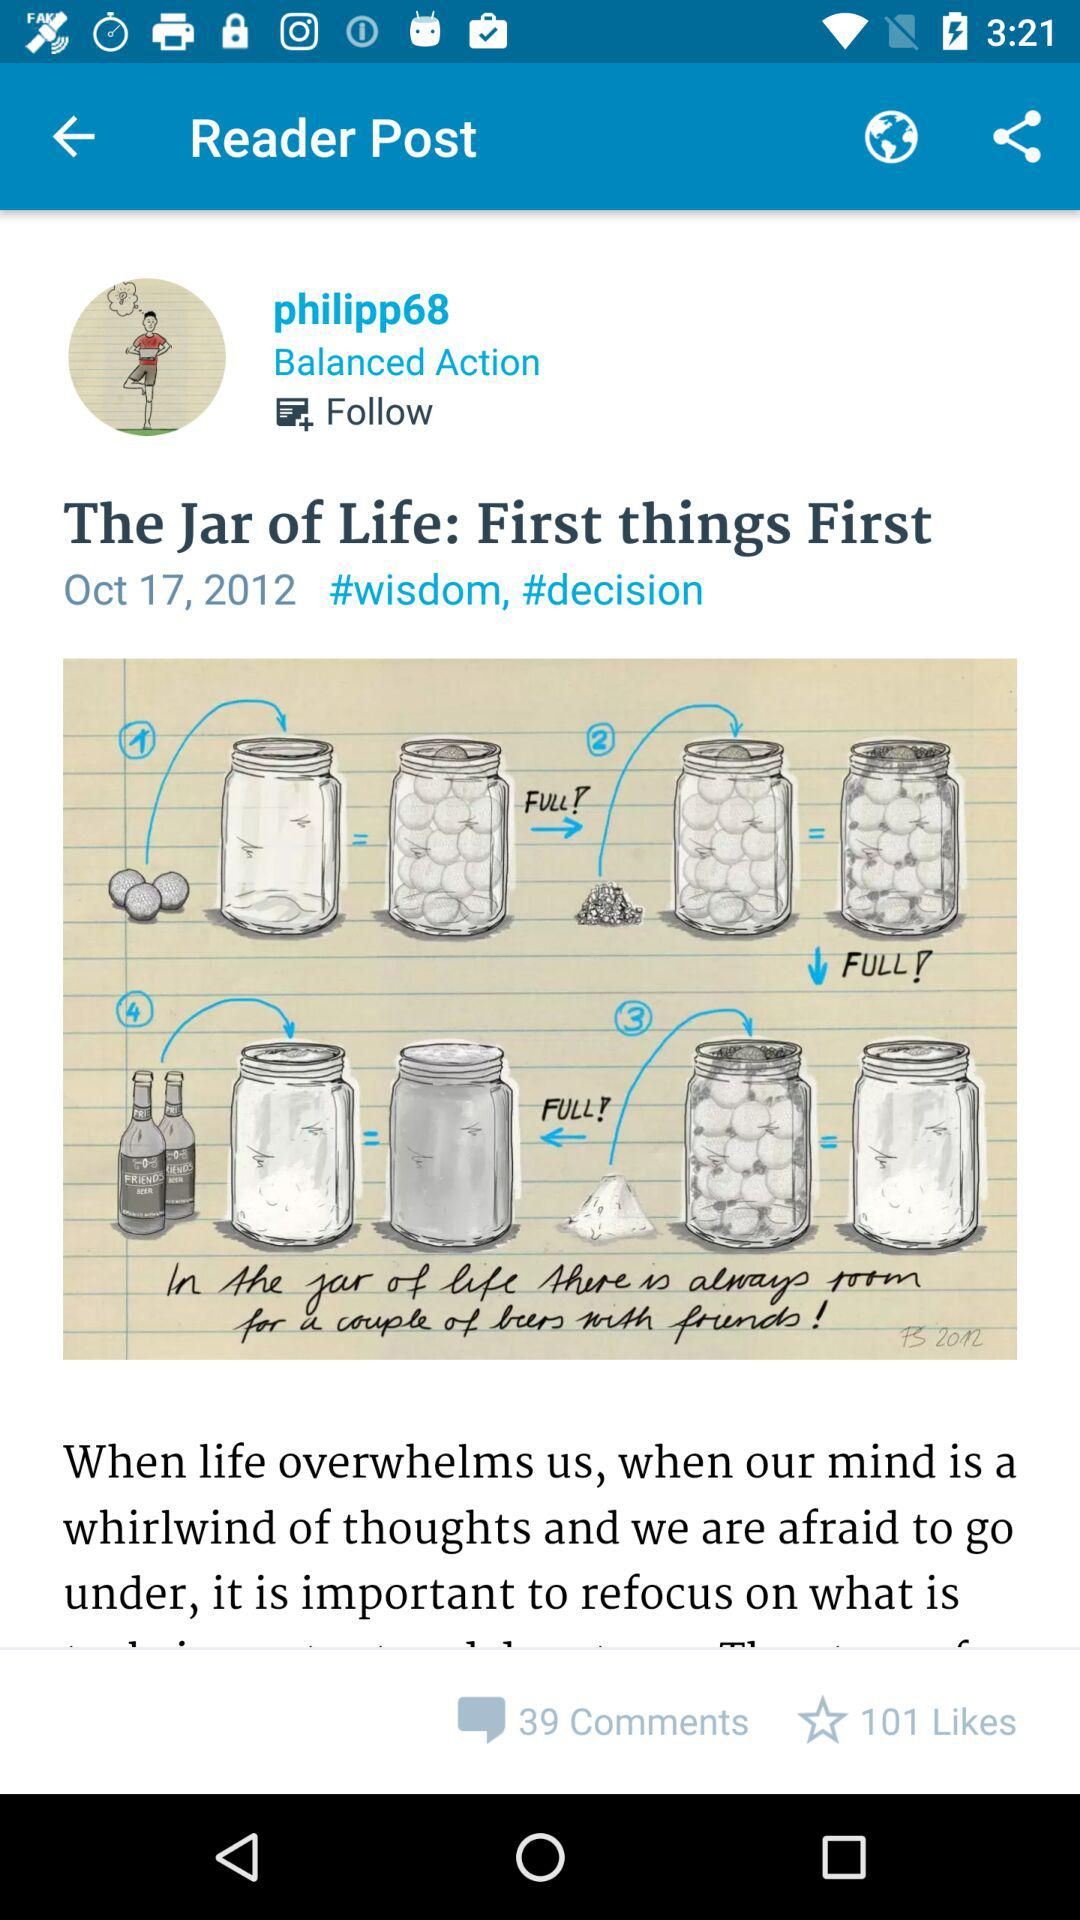How many comments are on the post? The comments are 39. 